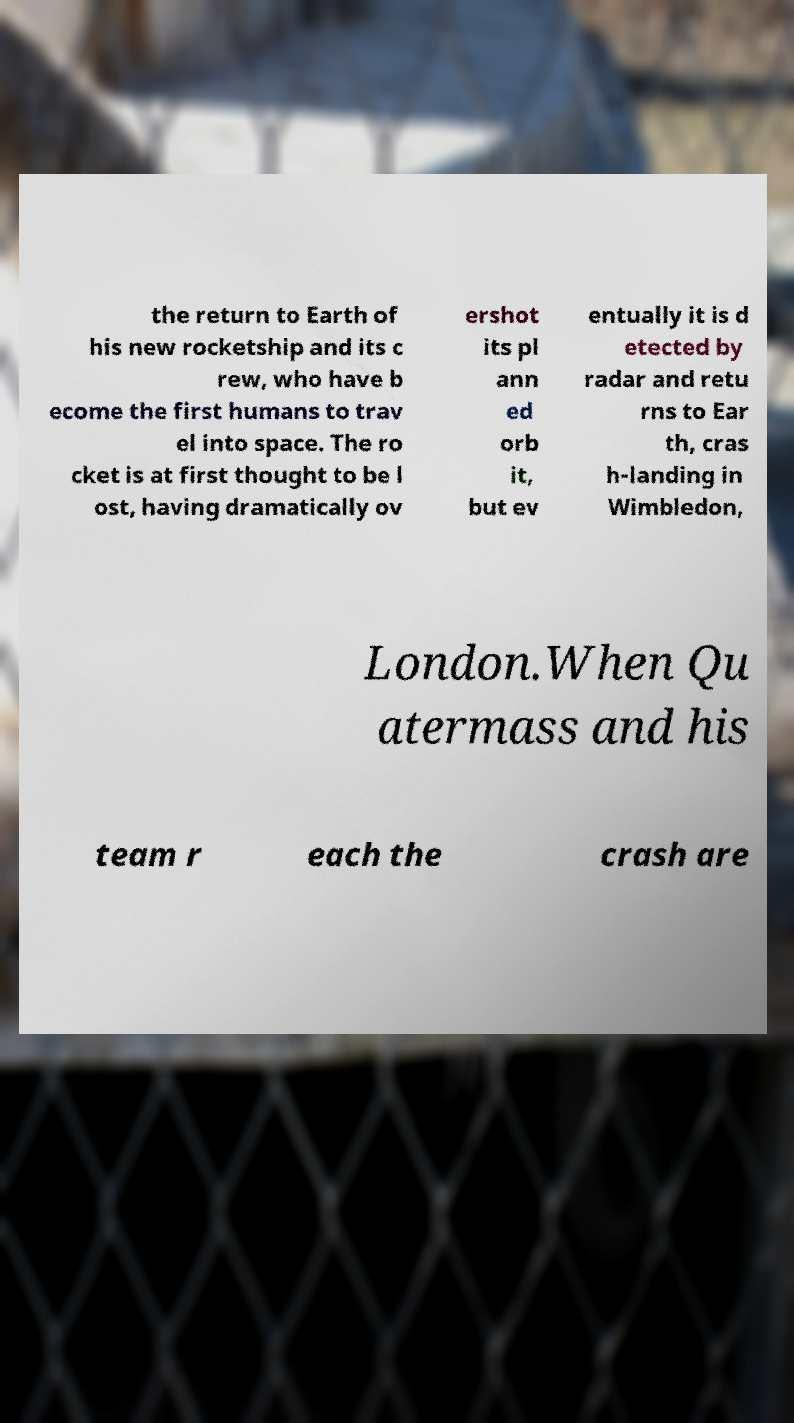Could you extract and type out the text from this image? the return to Earth of his new rocketship and its c rew, who have b ecome the first humans to trav el into space. The ro cket is at first thought to be l ost, having dramatically ov ershot its pl ann ed orb it, but ev entually it is d etected by radar and retu rns to Ear th, cras h-landing in Wimbledon, London.When Qu atermass and his team r each the crash are 